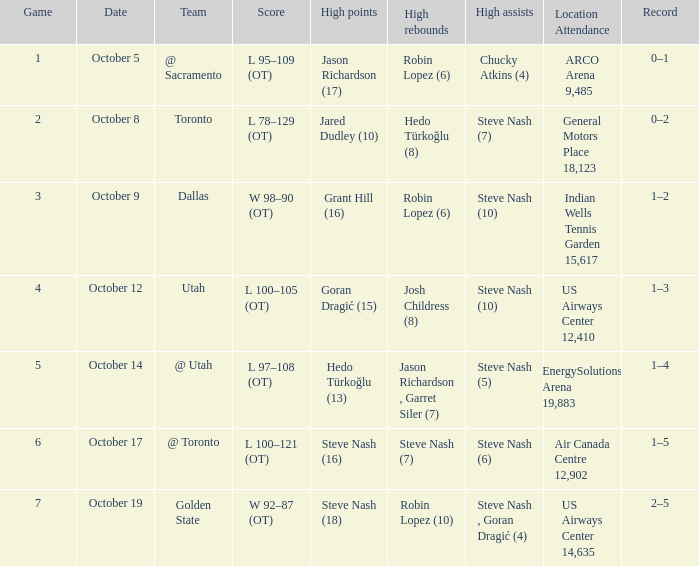Would you mind parsing the complete table? {'header': ['Game', 'Date', 'Team', 'Score', 'High points', 'High rebounds', 'High assists', 'Location Attendance', 'Record'], 'rows': [['1', 'October 5', '@ Sacramento', 'L 95–109 (OT)', 'Jason Richardson (17)', 'Robin Lopez (6)', 'Chucky Atkins (4)', 'ARCO Arena 9,485', '0–1'], ['2', 'October 8', 'Toronto', 'L 78–129 (OT)', 'Jared Dudley (10)', 'Hedo Türkoğlu (8)', 'Steve Nash (7)', 'General Motors Place 18,123', '0–2'], ['3', 'October 9', 'Dallas', 'W 98–90 (OT)', 'Grant Hill (16)', 'Robin Lopez (6)', 'Steve Nash (10)', 'Indian Wells Tennis Garden 15,617', '1–2'], ['4', 'October 12', 'Utah', 'L 100–105 (OT)', 'Goran Dragić (15)', 'Josh Childress (8)', 'Steve Nash (10)', 'US Airways Center 12,410', '1–3'], ['5', 'October 14', '@ Utah', 'L 97–108 (OT)', 'Hedo Türkoğlu (13)', 'Jason Richardson , Garret Siler (7)', 'Steve Nash (5)', 'EnergySolutions Arena 19,883', '1–4'], ['6', 'October 17', '@ Toronto', 'L 100–121 (OT)', 'Steve Nash (16)', 'Steve Nash (7)', 'Steve Nash (6)', 'Air Canada Centre 12,902', '1–5'], ['7', 'October 19', 'Golden State', 'W 92–87 (OT)', 'Steve Nash (18)', 'Robin Lopez (10)', 'Steve Nash , Goran Dragić (4)', 'US Airways Center 14,635', '2–5']]} What two players had the highest rebounds for the October 14 game? Jason Richardson , Garret Siler (7). 